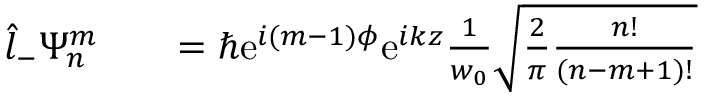<formula> <loc_0><loc_0><loc_500><loc_500>\begin{array} { r l r } { \hat { l } _ { - } \Psi _ { n } ^ { m } } & { = \hbar { e } ^ { i ( m - 1 ) \phi } e ^ { i k z } \frac { 1 } { w _ { 0 } } \sqrt { \frac { 2 } { \pi } \frac { n ! } { ( n - m + 1 ) ! } } } \end{array}</formula> 